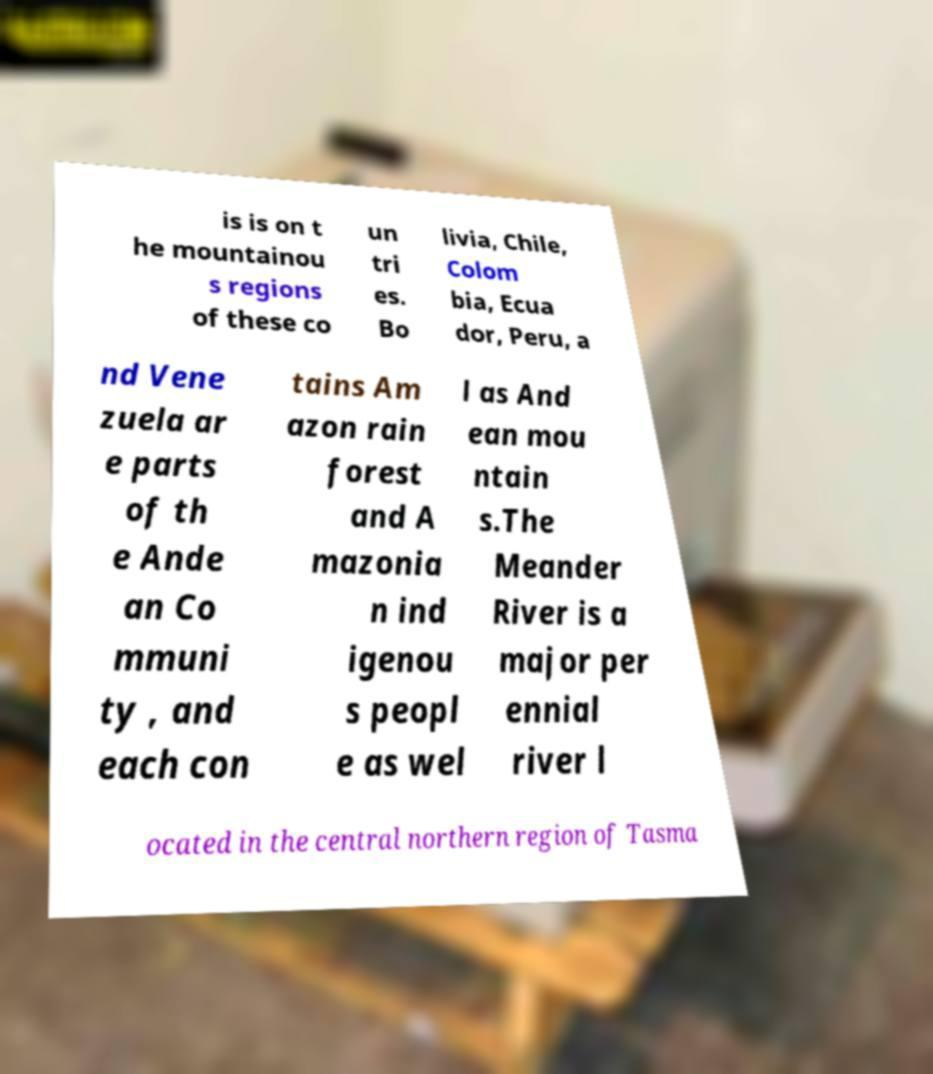Could you assist in decoding the text presented in this image and type it out clearly? is is on t he mountainou s regions of these co un tri es. Bo livia, Chile, Colom bia, Ecua dor, Peru, a nd Vene zuela ar e parts of th e Ande an Co mmuni ty , and each con tains Am azon rain forest and A mazonia n ind igenou s peopl e as wel l as And ean mou ntain s.The Meander River is a major per ennial river l ocated in the central northern region of Tasma 